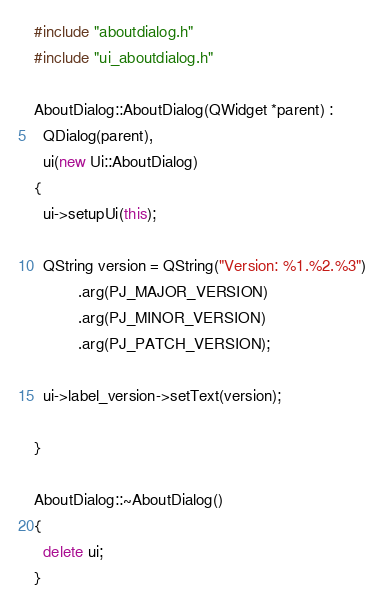Convert code to text. <code><loc_0><loc_0><loc_500><loc_500><_C++_>#include "aboutdialog.h"
#include "ui_aboutdialog.h"

AboutDialog::AboutDialog(QWidget *parent) :
  QDialog(parent),
  ui(new Ui::AboutDialog)
{
  ui->setupUi(this);

  QString version = QString("Version: %1.%2.%3")
          .arg(PJ_MAJOR_VERSION)
          .arg(PJ_MINOR_VERSION)
          .arg(PJ_PATCH_VERSION);

  ui->label_version->setText(version);

}

AboutDialog::~AboutDialog()
{
  delete ui;
}
</code> 